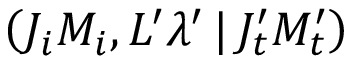Convert formula to latex. <formula><loc_0><loc_0><loc_500><loc_500>\left ( J _ { i } M _ { i } , L ^ { \prime } \lambda ^ { \prime } \, | \, J _ { t } ^ { \prime } M _ { t } ^ { \prime } \right )</formula> 